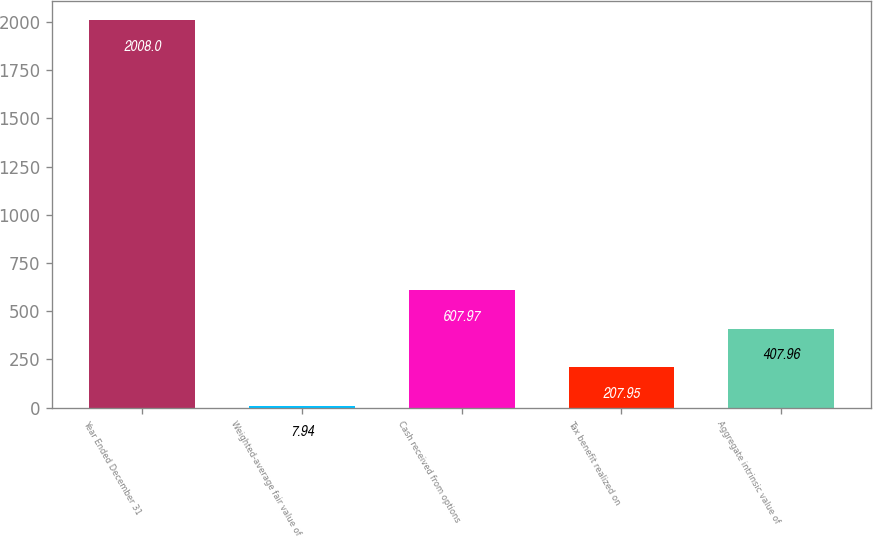<chart> <loc_0><loc_0><loc_500><loc_500><bar_chart><fcel>Year Ended December 31<fcel>Weighted-average fair value of<fcel>Cash received from options<fcel>Tax benefit realized on<fcel>Aggregate intrinsic value of<nl><fcel>2008<fcel>7.94<fcel>607.97<fcel>207.95<fcel>407.96<nl></chart> 